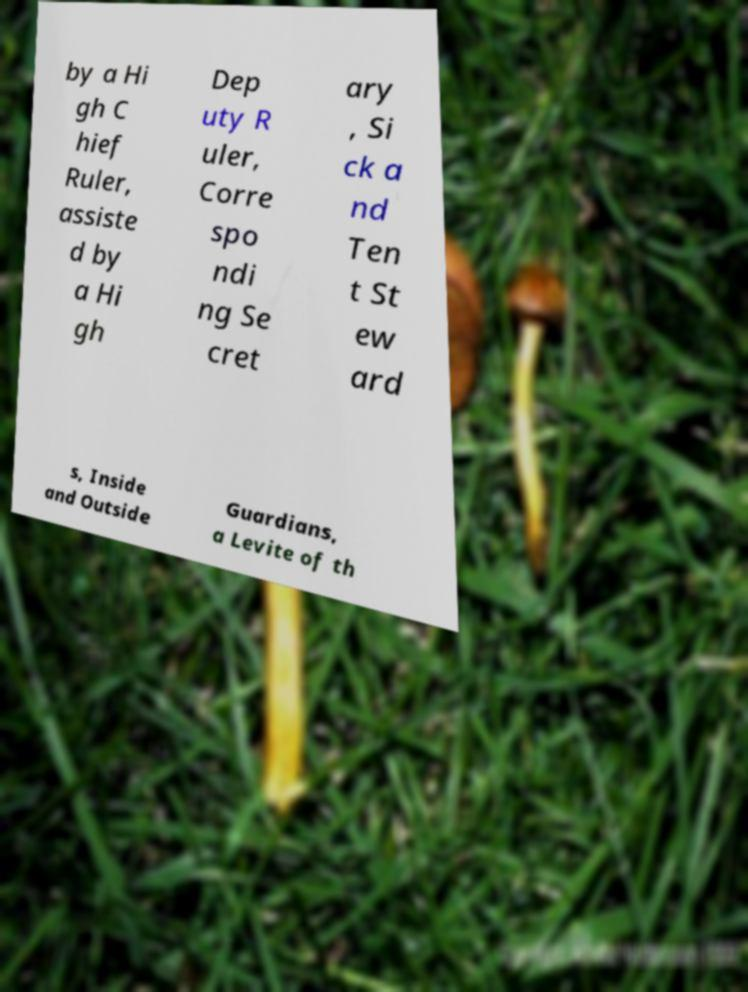Please read and relay the text visible in this image. What does it say? by a Hi gh C hief Ruler, assiste d by a Hi gh Dep uty R uler, Corre spo ndi ng Se cret ary , Si ck a nd Ten t St ew ard s, Inside and Outside Guardians, a Levite of th 